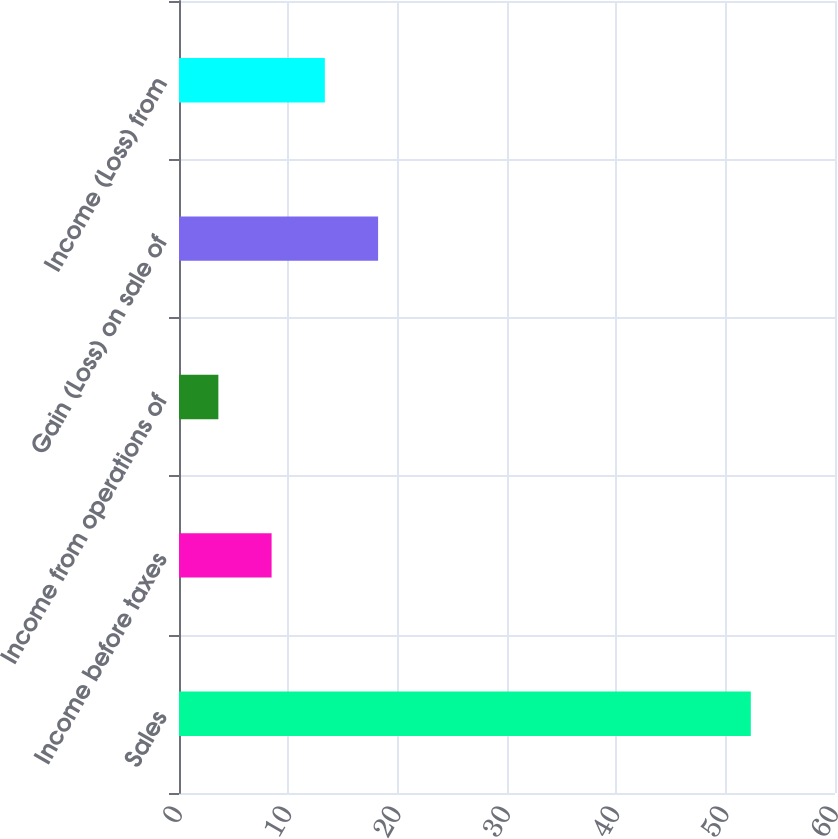<chart> <loc_0><loc_0><loc_500><loc_500><bar_chart><fcel>Sales<fcel>Income before taxes<fcel>Income from operations of<fcel>Gain (Loss) on sale of<fcel>Income (Loss) from<nl><fcel>52.3<fcel>8.47<fcel>3.6<fcel>18.21<fcel>13.34<nl></chart> 